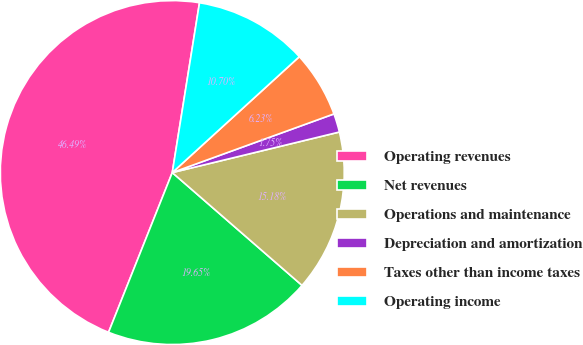<chart> <loc_0><loc_0><loc_500><loc_500><pie_chart><fcel>Operating revenues<fcel>Net revenues<fcel>Operations and maintenance<fcel>Depreciation and amortization<fcel>Taxes other than income taxes<fcel>Operating income<nl><fcel>46.49%<fcel>19.65%<fcel>15.18%<fcel>1.75%<fcel>6.23%<fcel>10.7%<nl></chart> 